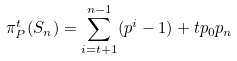<formula> <loc_0><loc_0><loc_500><loc_500>\pi _ { P } ^ { t } ( S _ { n } ) = \sum _ { i = t + 1 } ^ { n - 1 } ( p ^ { i } - 1 ) + t p _ { 0 } p _ { n }</formula> 